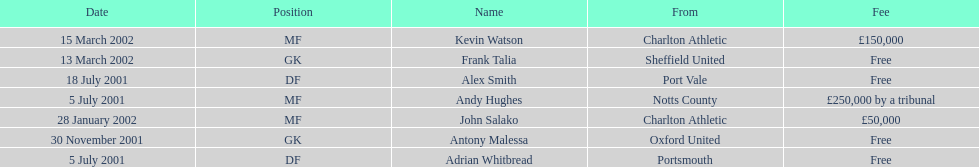What was the transfer fee to transfer kevin watson? £150,000. 